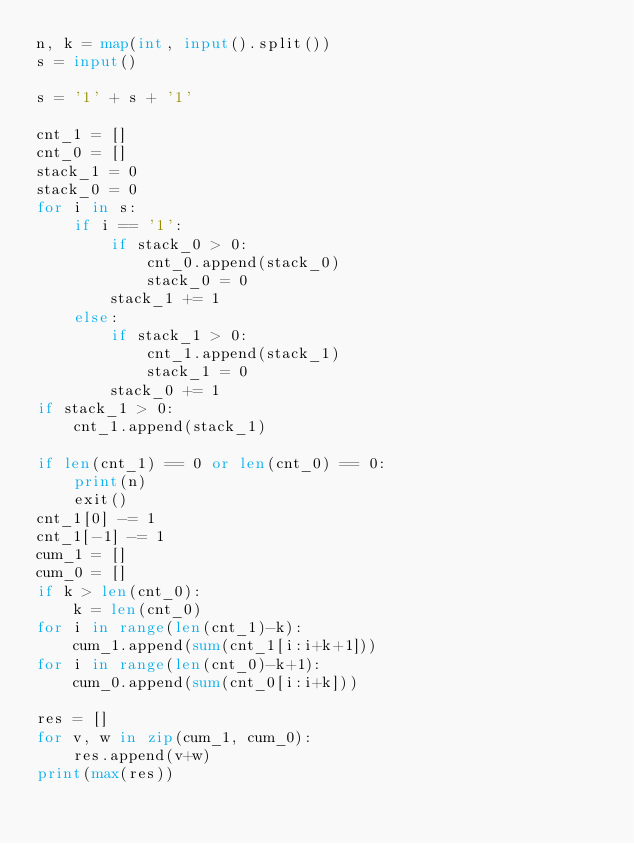<code> <loc_0><loc_0><loc_500><loc_500><_Python_>n, k = map(int, input().split())
s = input()

s = '1' + s + '1'

cnt_1 = []
cnt_0 = []
stack_1 = 0
stack_0 = 0
for i in s:
    if i == '1':
        if stack_0 > 0:
            cnt_0.append(stack_0)
            stack_0 = 0
        stack_1 += 1
    else:
        if stack_1 > 0:
            cnt_1.append(stack_1)
            stack_1 = 0
        stack_0 += 1
if stack_1 > 0:
    cnt_1.append(stack_1)

if len(cnt_1) == 0 or len(cnt_0) == 0:
    print(n)
    exit()
cnt_1[0] -= 1
cnt_1[-1] -= 1
cum_1 = []
cum_0 = []
if k > len(cnt_0):
    k = len(cnt_0)
for i in range(len(cnt_1)-k):
    cum_1.append(sum(cnt_1[i:i+k+1]))
for i in range(len(cnt_0)-k+1):
    cum_0.append(sum(cnt_0[i:i+k]))

res = []
for v, w in zip(cum_1, cum_0):
    res.append(v+w)
print(max(res))</code> 